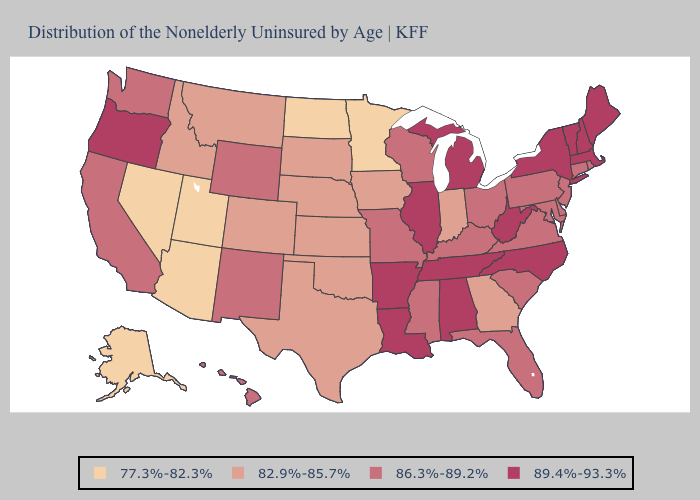Does the map have missing data?
Keep it brief. No. Among the states that border Florida , does Alabama have the lowest value?
Quick response, please. No. Name the states that have a value in the range 77.3%-82.3%?
Answer briefly. Alaska, Arizona, Minnesota, Nevada, North Dakota, Utah. What is the highest value in the MidWest ?
Give a very brief answer. 89.4%-93.3%. What is the lowest value in the MidWest?
Keep it brief. 77.3%-82.3%. What is the value of Arizona?
Short answer required. 77.3%-82.3%. Does the first symbol in the legend represent the smallest category?
Concise answer only. Yes. Does Nevada have a lower value than New York?
Keep it brief. Yes. What is the value of Arizona?
Be succinct. 77.3%-82.3%. Does Florida have the lowest value in the USA?
Concise answer only. No. Does Missouri have a higher value than Utah?
Short answer required. Yes. Among the states that border Iowa , does Illinois have the highest value?
Answer briefly. Yes. Which states hav the highest value in the MidWest?
Keep it brief. Illinois, Michigan. Which states have the lowest value in the Northeast?
Keep it brief. Connecticut, New Jersey, Pennsylvania, Rhode Island. Among the states that border Kentucky , which have the highest value?
Answer briefly. Illinois, Tennessee, West Virginia. 